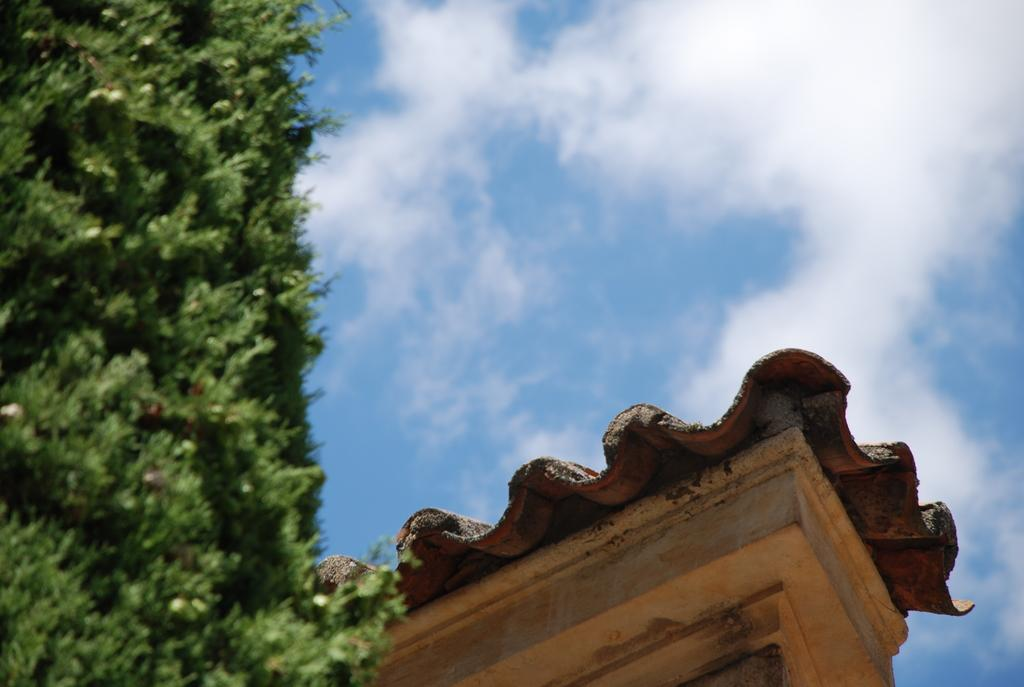What is present above the main subject in the image? There is a roof in the image. What color is the sky in the image? The sky is blue in the image. Are there any weather elements visible in the sky? Yes, there are clouds in the sky in the image. How are the trees depicted in the image? The trees are blurred in the image. Can you tell me where the nearest zoo is in the image? There is no information about a zoo in the image, so it cannot be determined from the image. 